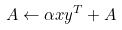<formula> <loc_0><loc_0><loc_500><loc_500>A \leftarrow \alpha x y ^ { T } + A</formula> 